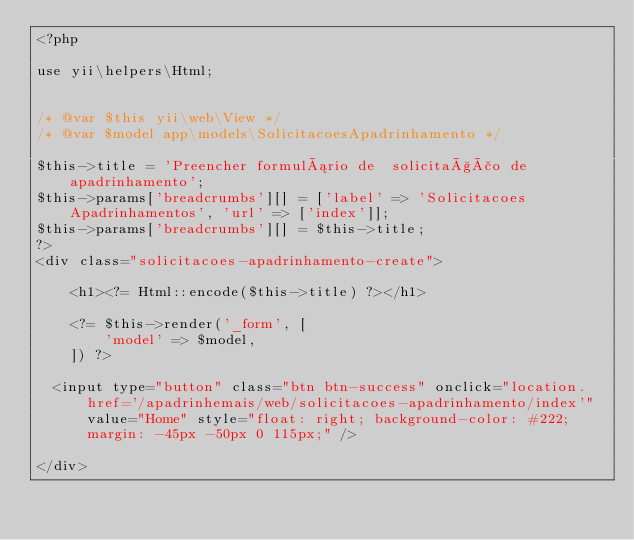Convert code to text. <code><loc_0><loc_0><loc_500><loc_500><_PHP_><?php

use yii\helpers\Html;


/* @var $this yii\web\View */
/* @var $model app\models\SolicitacoesApadrinhamento */

$this->title = 'Preencher formulário de  solicitação de apadrinhamento';
$this->params['breadcrumbs'][] = ['label' => 'Solicitacoes Apadrinhamentos', 'url' => ['index']];
$this->params['breadcrumbs'][] = $this->title;
?>
<div class="solicitacoes-apadrinhamento-create">

    <h1><?= Html::encode($this->title) ?></h1>

    <?= $this->render('_form', [
        'model' => $model,
    ]) ?>

	<input type="button" class="btn btn-success" onclick="location.href='/apadrinhemais/web/solicitacoes-apadrinhamento/index'" value="Home" style="float: right; background-color: #222; margin: -45px -50px 0 115px;" />
	
</div>
</code> 